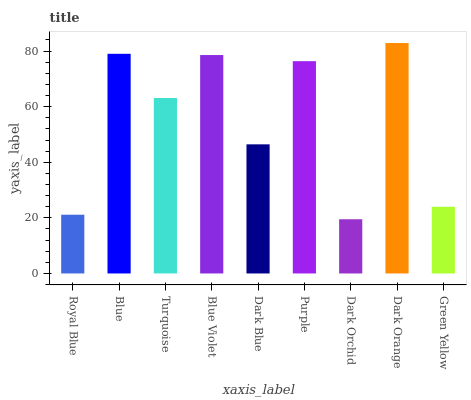Is Dark Orchid the minimum?
Answer yes or no. Yes. Is Dark Orange the maximum?
Answer yes or no. Yes. Is Blue the minimum?
Answer yes or no. No. Is Blue the maximum?
Answer yes or no. No. Is Blue greater than Royal Blue?
Answer yes or no. Yes. Is Royal Blue less than Blue?
Answer yes or no. Yes. Is Royal Blue greater than Blue?
Answer yes or no. No. Is Blue less than Royal Blue?
Answer yes or no. No. Is Turquoise the high median?
Answer yes or no. Yes. Is Turquoise the low median?
Answer yes or no. Yes. Is Dark Orchid the high median?
Answer yes or no. No. Is Royal Blue the low median?
Answer yes or no. No. 